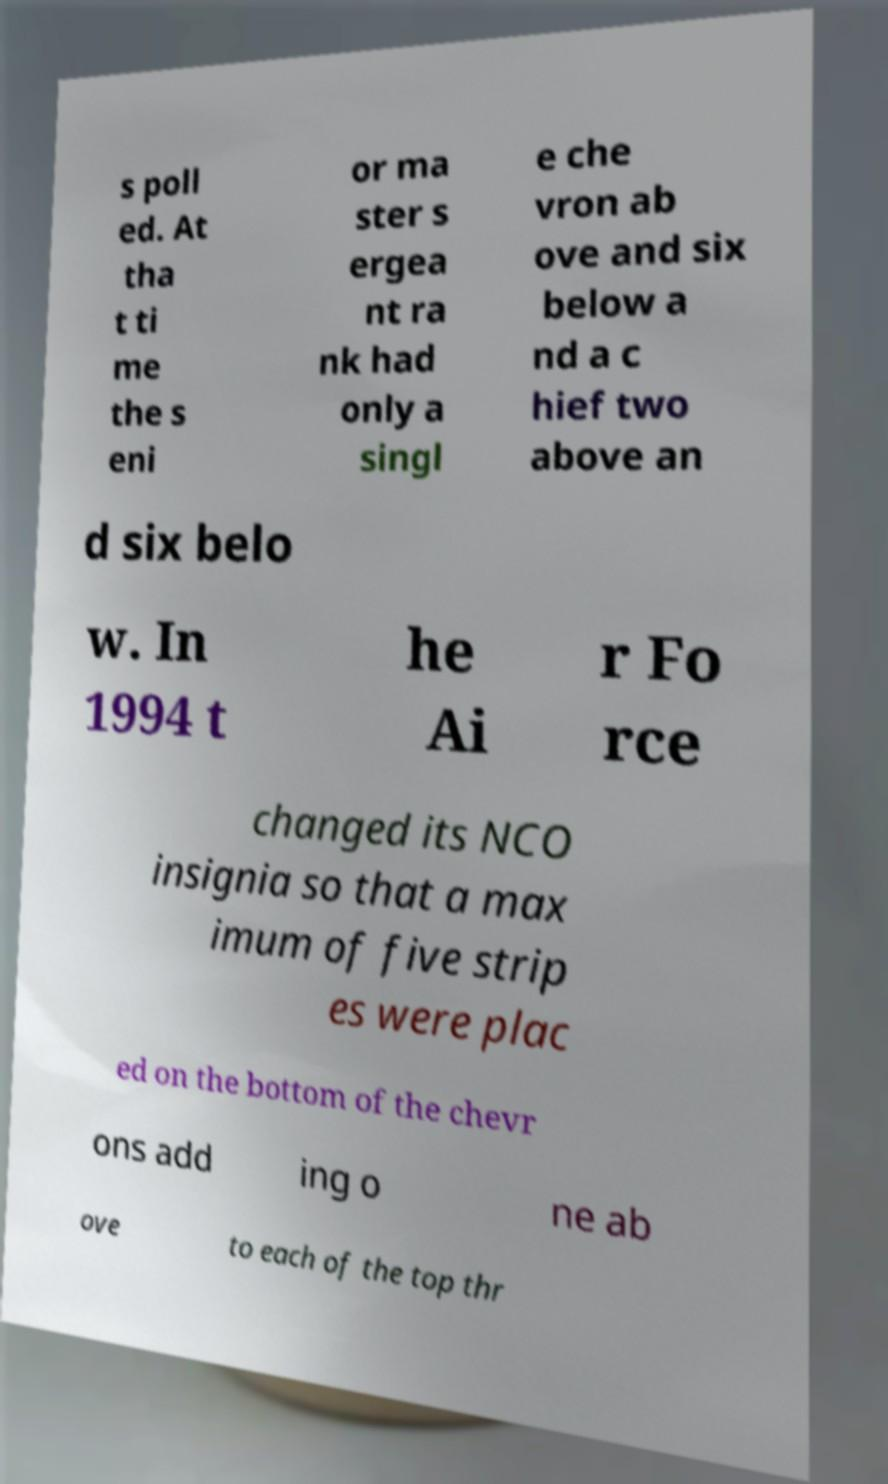For documentation purposes, I need the text within this image transcribed. Could you provide that? s poll ed. At tha t ti me the s eni or ma ster s ergea nt ra nk had only a singl e che vron ab ove and six below a nd a c hief two above an d six belo w. In 1994 t he Ai r Fo rce changed its NCO insignia so that a max imum of five strip es were plac ed on the bottom of the chevr ons add ing o ne ab ove to each of the top thr 